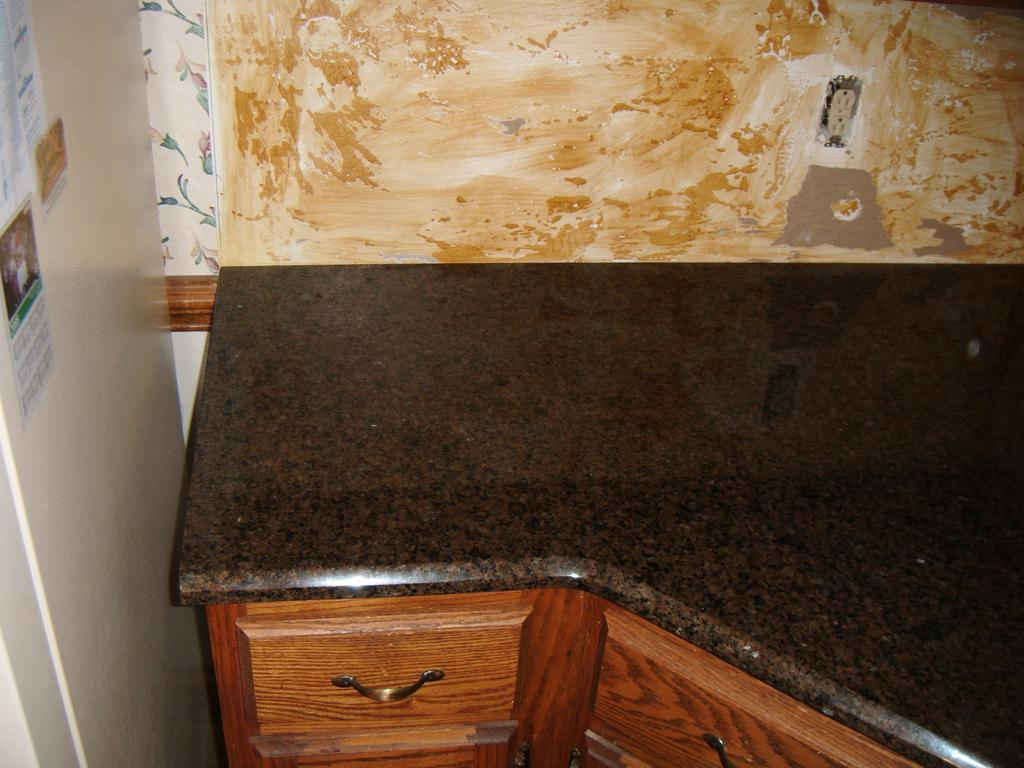What type of furniture is present in the image? There are drawers in the image. What can be seen on the left side of the image? There are posters on the left side of the image. What is visible in the background of the image? There is a wall in the background of the image. Where is the kettle located in the image? There is no kettle present in the image. What type of rail is visible in the image? There is no rail present in the image. 